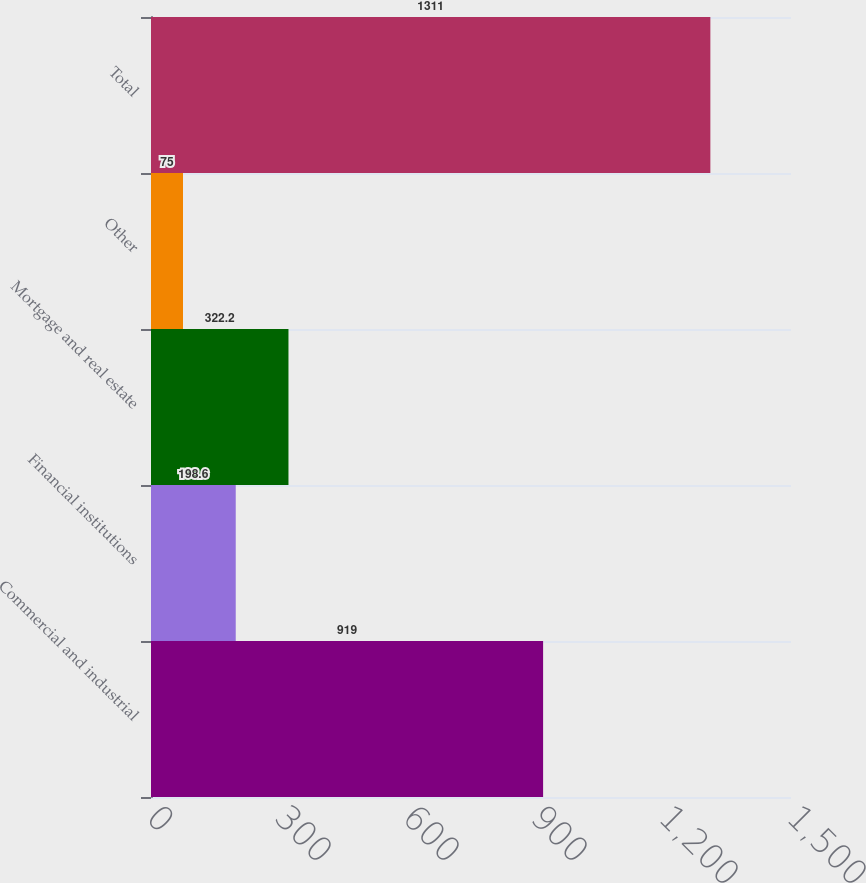Convert chart. <chart><loc_0><loc_0><loc_500><loc_500><bar_chart><fcel>Commercial and industrial<fcel>Financial institutions<fcel>Mortgage and real estate<fcel>Other<fcel>Total<nl><fcel>919<fcel>198.6<fcel>322.2<fcel>75<fcel>1311<nl></chart> 